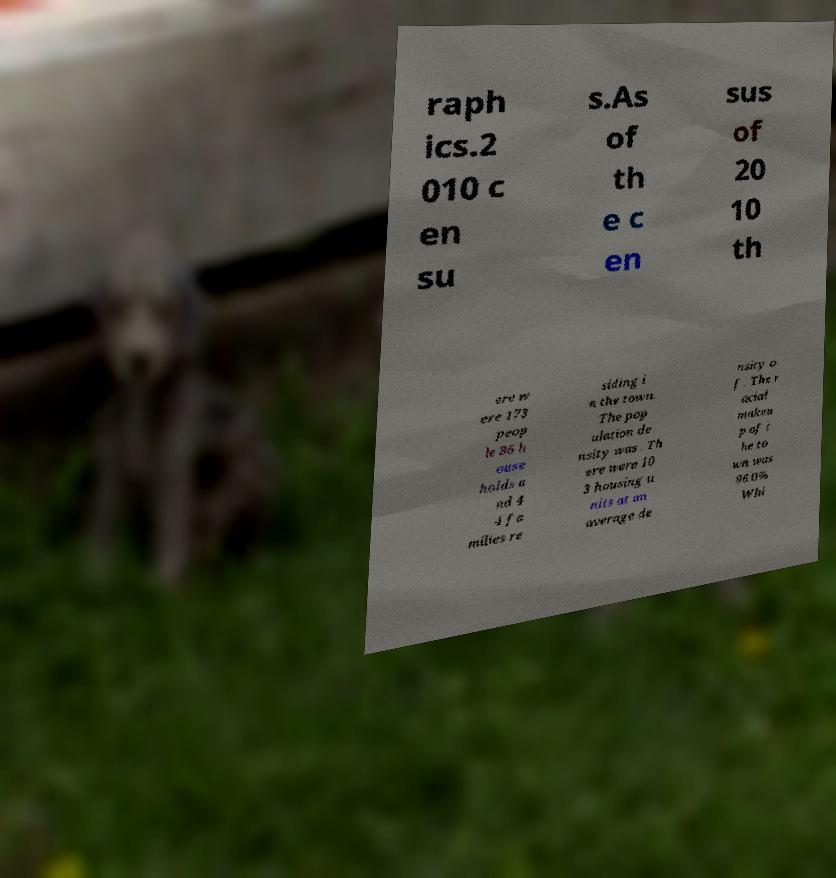Could you extract and type out the text from this image? raph ics.2 010 c en su s.As of th e c en sus of 20 10 th ere w ere 173 peop le 86 h ouse holds a nd 4 4 fa milies re siding i n the town. The pop ulation de nsity was . Th ere were 10 3 housing u nits at an average de nsity o f . The r acial makeu p of t he to wn was 96.0% Whi 